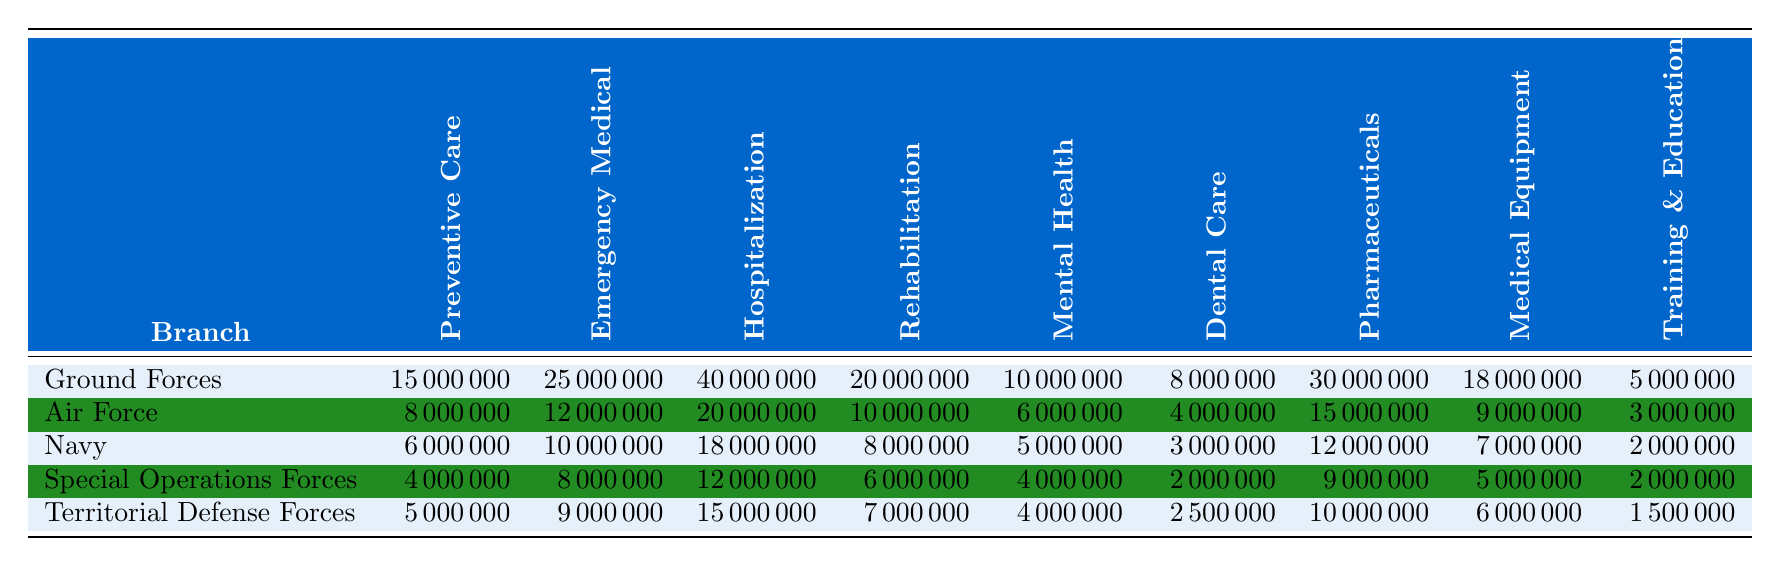What is the highest annual expenditure on hospitalization among the branches? The table shows that the Ground Forces have the highest expenditure on hospitalization at 40,000,000.
Answer: 40,000,000 Which branch has the lowest spending on dental care? The table indicates that the Special Operations Forces have the lowest spending on dental care with an expenditure of 2,000,000.
Answer: 2,000,000 What is the total expenditure on emergency medical services for the Ground Forces and Navy? To find the total, add the emergency medical expenditures for both branches: Ground Forces (25,000,000) + Navy (10,000,000) = 35,000,000.
Answer: 35,000,000 Is the annual expenditure on preventive care for the Air Force greater than that for the Navy? The Air Force spends 8,000,000 on preventive care, while the Navy spends 6,000,000, so yes, the Air Force spending is greater.
Answer: Yes What is the average spending on pharmaceuticals across all branches? First, sum the pharmaceuticals expenditures: 30,000,000 (Ground Forces) + 15,000,000 (Air Force) + 12,000,000 (Navy) + 9,000,000 (Special Operations) + 10,000,000 (Territorial Defense) = 76,000,000. There are 5 branches, so the average is 76,000,000 / 5 = 15,200,000.
Answer: 15,200,000 Which branch spends the most on mental health services relative to its total expenditure? Calculate the total expenditure for each branch, then find the ratio of mental health services to total expenditure. For Ground Forces, the total is 105,000,000 (sum all categories), mental health services are 10,000,000, so the ratio is 10,000,000 / 105,000,000 = 0.095. Repeat for other branches; the Special Operations Forces have the highest ratio at 4,000,000 / 50,000,000 = 0.08.
Answer: Special Operations Forces What is the total annual expenditure for the Territorial Defense Forces? Add all expenditures for the Territorial Defense Forces: 5,000,000 (Preventive Care) + 9,000,000 (Emergency Medical Services) + 15,000,000 (Hospitalization) + 7,000,000 (Rehabilitation) + 4,000,000 (Mental Health Services) + 2,500,000 (Dental Care) + 10,000,000 (Pharmaceuticals) + 6,000,000 (Medical Equipment) + 1,500,000 (Training and Education) = 60,000,000.
Answer: 60,000,000 Which branch spends the least overall on rehabilitation services? The data shows that the Special Operations Forces spend the least on rehabilitation services at 6,000,000.
Answer: 6,000,000 Is the total expenditure on training and education by the Air Force higher than the total for the Navy? The Air Force spends 3,000,000 on training and education, while the Navy spends 2,000,000, so yes, the expenditure of the Air Force is higher.
Answer: Yes How much more does the Ground Forces spend on pharmaceuticals compared to the Special Operations Forces? Ground Forces spend 30,000,000 on pharmaceuticals, while Special Operations Forces spend 9,000,000. The difference is 30,000,000 - 9,000,000 = 21,000,000.
Answer: 21,000,000 